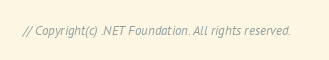<code> <loc_0><loc_0><loc_500><loc_500><_C#_>// Copyright(c) .NET Foundation. All rights reserved.</code> 